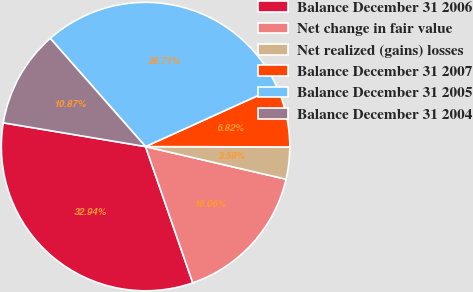Convert chart. <chart><loc_0><loc_0><loc_500><loc_500><pie_chart><fcel>Balance December 31 2006<fcel>Net change in fair value<fcel>Net realized (gains) losses<fcel>Balance December 31 2007<fcel>Balance December 31 2005<fcel>Balance December 31 2004<nl><fcel>32.94%<fcel>16.06%<fcel>3.59%<fcel>6.82%<fcel>29.71%<fcel>10.87%<nl></chart> 